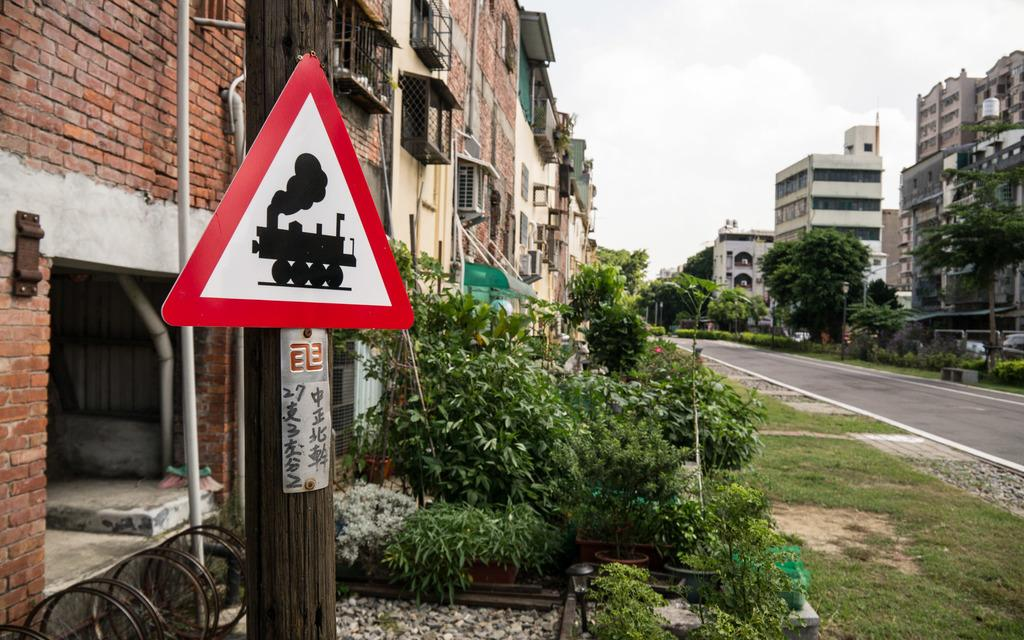<image>
Render a clear and concise summary of the photo. A sign has an image of a train on it and Asian symbols below it. 